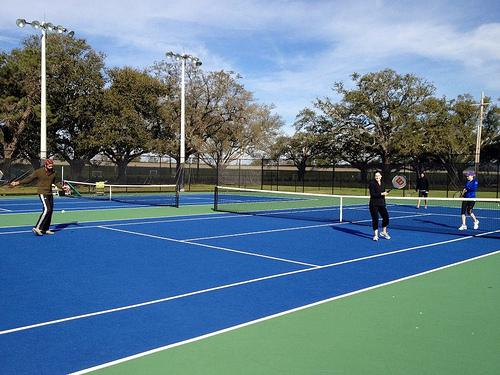Question: when this picture was taken?
Choices:
A. Night.
B. Dusk.
C. During the day.
D. Dawn.
Answer with the letter. Answer: C Question: where this picture was taken?
Choices:
A. Gym.
B. On a tennis court.
C. Baseball park.
D. Golf course.
Answer with the letter. Answer: B Question: who is playing tennis?
Choices:
A. Two men and two women.
B. Two kids.
C. A man.
D. A child.
Answer with the letter. Answer: A Question: what are these people are doing?
Choices:
A. Running.
B. Resting.
C. Doing situps.
D. Playing tennis.
Answer with the letter. Answer: D Question: who is wearing a blue blouse?
Choices:
A. The man.
B. The girl.
C. The boy.
D. A woman.
Answer with the letter. Answer: D Question: what is the color of the tennis court?
Choices:
A. Purple.
B. Yellow.
C. White.
D. Blue and green.
Answer with the letter. Answer: D Question: how many people are playing?
Choices:
A. Two.
B. Six.
C. Three.
D. Four.
Answer with the letter. Answer: D 